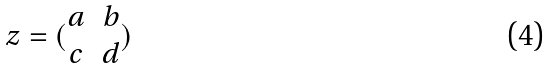Convert formula to latex. <formula><loc_0><loc_0><loc_500><loc_500>z = ( \begin{matrix} a & b \\ c & d \end{matrix} )</formula> 